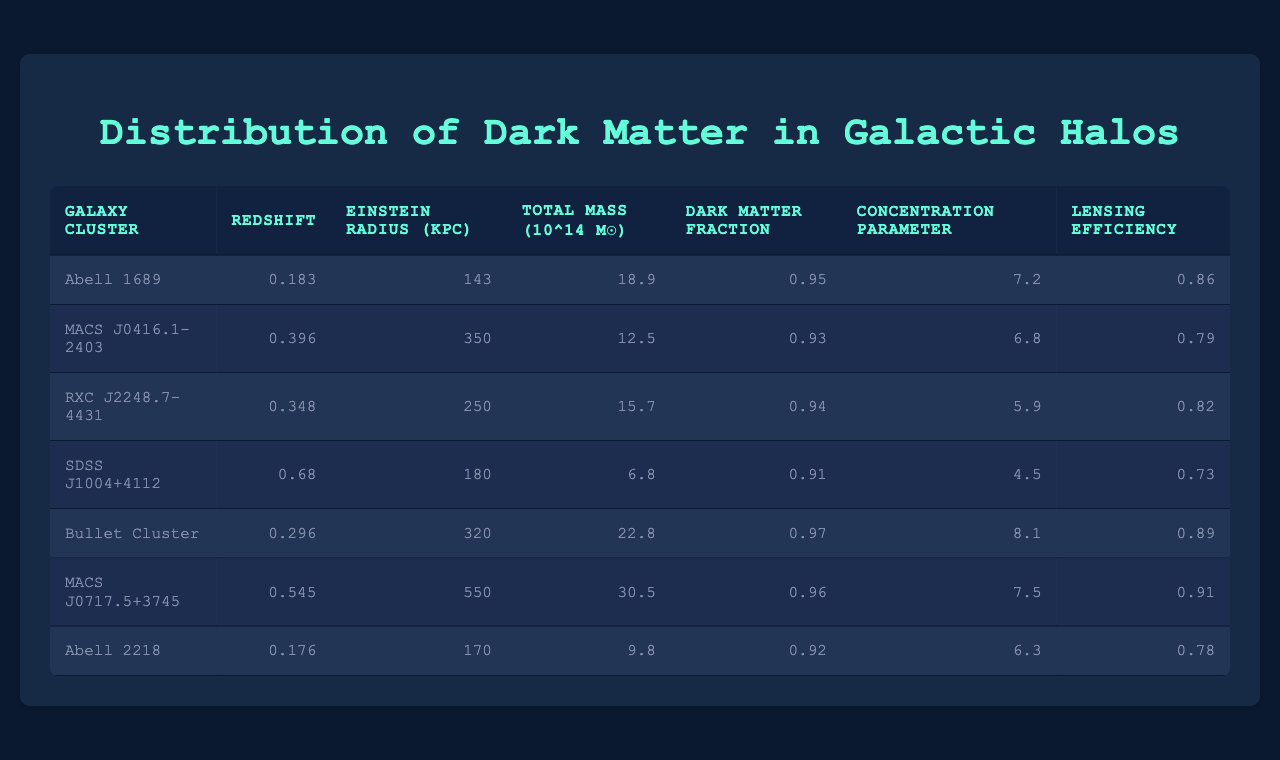What is the total mass of the Bullet Cluster? The Bullet Cluster's total mass is listed in the table under the "Total Mass" column, which indicates a value of 22.8 (10^14 M☉).
Answer: 22.8 (10^14 M☉) Which galaxy cluster has the highest concentration parameter? By comparing the values in the "Concentration Parameter" column, MACS J0717.5+3745 has the highest value at 7.5.
Answer: MACS J0717.5+3745 What is the mean dark matter fraction across all clusters? To calculate the mean, sum all the dark matter fractions: (0.95 + 0.93 + 0.94 + 0.91 + 0.97 + 0.96 + 0.92) = 6.58, and then divide by the number of clusters (7): 6.58/7 ≈ 0.94.
Answer: 0.94 Is the lensing efficiency for RXC J2248.7-4431 greater than or equal to 0.8? The lensing efficiency for RXC J2248.7-4431 is 0.82, which is greater than 0.8.
Answer: Yes Which galaxy cluster has the largest Einstein radius? By examining the "Einstein Radius (kpc)" column, MACS J0717.5+3745 has the largest Einstein radius listed at 550 kpc.
Answer: MACS J0717.5+3745 What is the difference in total mass between Abell 1689 and SDSS J1004+4112? The total mass of Abell 1689 is 18.9 (10^14 M☉) and for SDSS J1004+4112 it is 6.8 (10^14 M☉). The difference is 18.9 - 6.8 = 12.1 (10^14 M☉).
Answer: 12.1 (10^14 M☉) Does any galaxy cluster have a dark matter fraction less than 0.90? Checking the "Dark Matter Fraction" column, the lowest value is 0.91, which means no cluster has a fraction below 0.90.
Answer: No Which cluster has the lowest lensing efficiency? The lensing efficiencies must be compared, with SDSS J1004+4112 being the lowest at 0.73.
Answer: SDSS J1004+4112 What is the average redshift of the clusters? Calculate the average redshift by summing all values: (0.183 + 0.396 + 0.348 + 0.68 + 0.296 + 0.545 + 0.176) = 2.63, and divide by the number of clusters (7): 2.63 / 7 ≈ 0.3757.
Answer: Approximately 0.376 Which galaxy cluster shows the highest dark matter fraction? Looking at the "Dark Matter Fraction" column, the highest value is 0.97 for the Bullet Cluster.
Answer: Bullet Cluster 